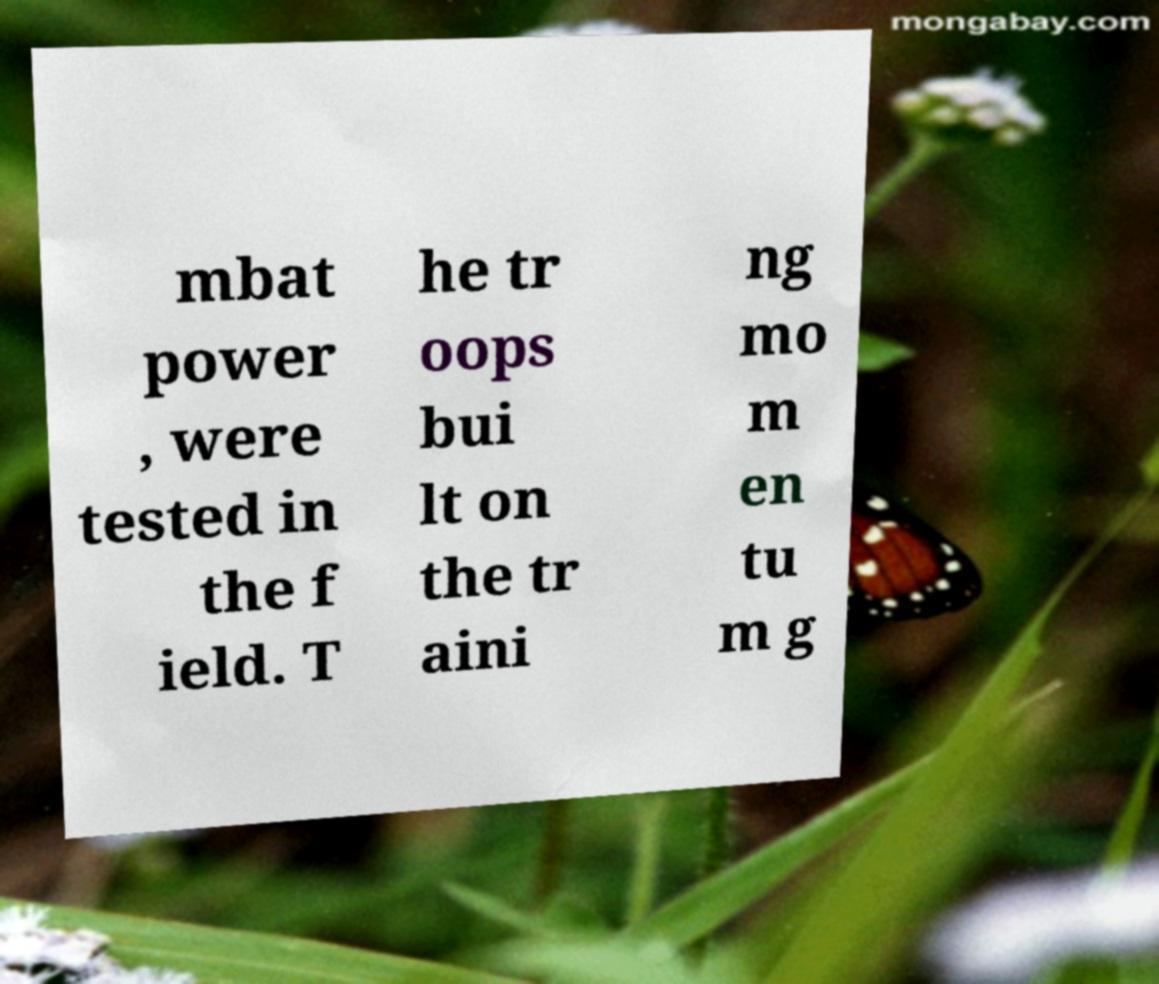Can you accurately transcribe the text from the provided image for me? mbat power , were tested in the f ield. T he tr oops bui lt on the tr aini ng mo m en tu m g 